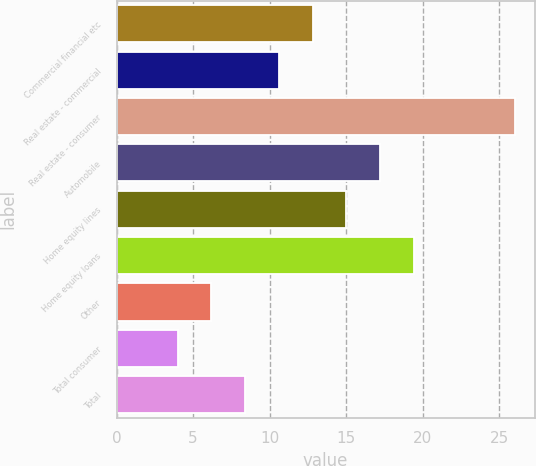Convert chart. <chart><loc_0><loc_0><loc_500><loc_500><bar_chart><fcel>Commercial financial etc<fcel>Real estate - commercial<fcel>Real estate - consumer<fcel>Automobile<fcel>Home equity lines<fcel>Home equity loans<fcel>Other<fcel>Total consumer<fcel>Total<nl><fcel>12.8<fcel>10.6<fcel>26<fcel>17.2<fcel>15<fcel>19.4<fcel>6.2<fcel>4<fcel>8.4<nl></chart> 